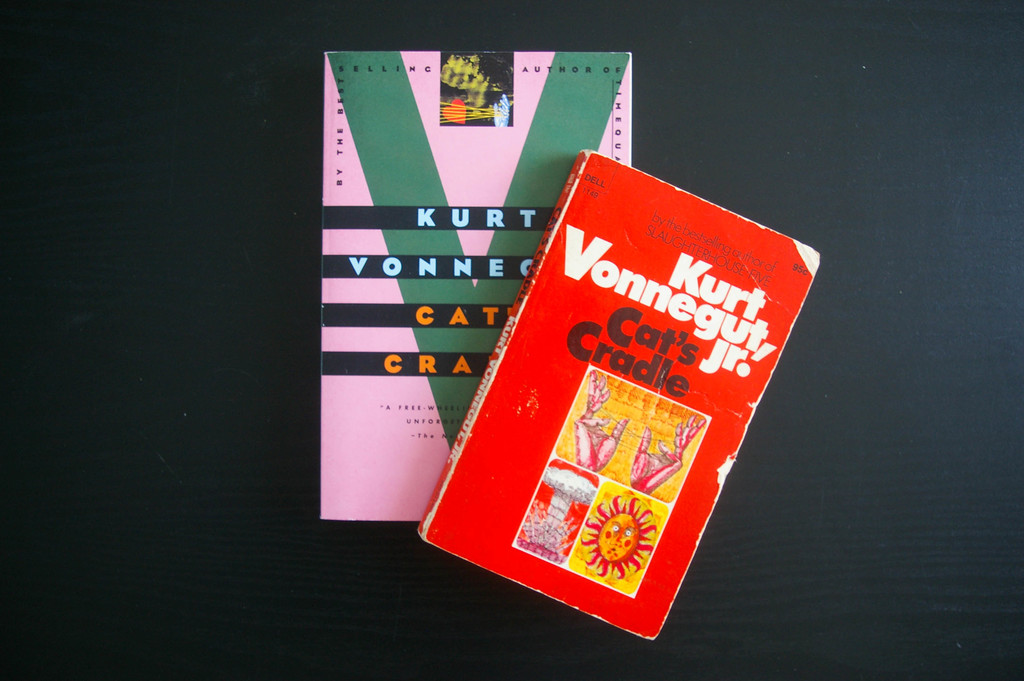How do the cover designs of these two books reflect the literary style or themes of Kurt Vonnegut's writings? The bright and quirky designs reflect Vonnegut's unique blend of satire and science fiction. The graphical elements, such as the 'Cat's Eye' and abstract patterns, encapsulate his approach to complex narratives filled with irony and philosophical ponderings. 